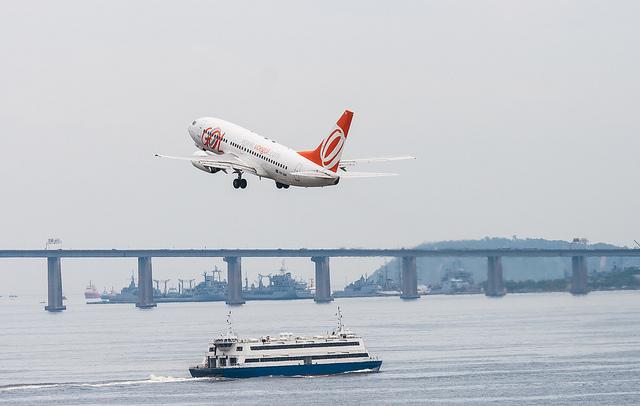What color is the plane?
Give a very brief answer. White and red. What kind of boat is shown?
Concise answer only. Ferry. Is the plane flying?
Short answer required. Yes. 